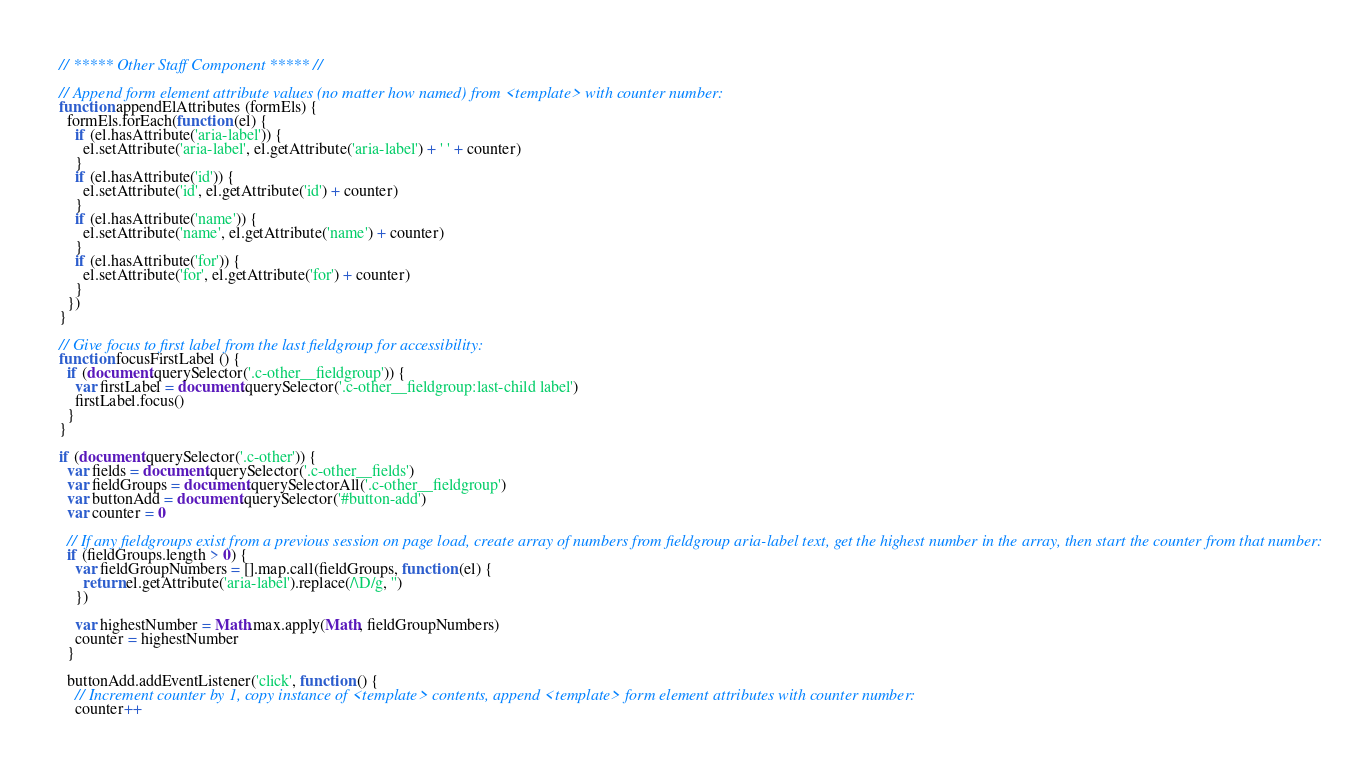<code> <loc_0><loc_0><loc_500><loc_500><_JavaScript_>// ***** Other Staff Component ***** //

// Append form element attribute values (no matter how named) from <template> with counter number:
function appendElAttributes (formEls) {
  formEls.forEach(function (el) {
    if (el.hasAttribute('aria-label')) {
      el.setAttribute('aria-label', el.getAttribute('aria-label') + ' ' + counter)
    }
    if (el.hasAttribute('id')) {
      el.setAttribute('id', el.getAttribute('id') + counter)
    }
    if (el.hasAttribute('name')) {
      el.setAttribute('name', el.getAttribute('name') + counter)
    }
    if (el.hasAttribute('for')) {
      el.setAttribute('for', el.getAttribute('for') + counter)
    }
  })
}

// Give focus to first label from the last fieldgroup for accessibility:
function focusFirstLabel () {
  if (document.querySelector('.c-other__fieldgroup')) {
    var firstLabel = document.querySelector('.c-other__fieldgroup:last-child label')
    firstLabel.focus()
  }
}

if (document.querySelector('.c-other')) {
  var fields = document.querySelector('.c-other__fields')
  var fieldGroups = document.querySelectorAll('.c-other__fieldgroup')
  var buttonAdd = document.querySelector('#button-add')
  var counter = 0

  // If any fieldgroups exist from a previous session on page load, create array of numbers from fieldgroup aria-label text, get the highest number in the array, then start the counter from that number:
  if (fieldGroups.length > 0) {
    var fieldGroupNumbers = [].map.call(fieldGroups, function (el) {
      return el.getAttribute('aria-label').replace(/\D/g, '')
    })

    var highestNumber = Math.max.apply(Math, fieldGroupNumbers)
    counter = highestNumber
  }

  buttonAdd.addEventListener('click', function () {
    // Increment counter by 1, copy instance of <template> contents, append <template> form element attributes with counter number:
    counter++</code> 